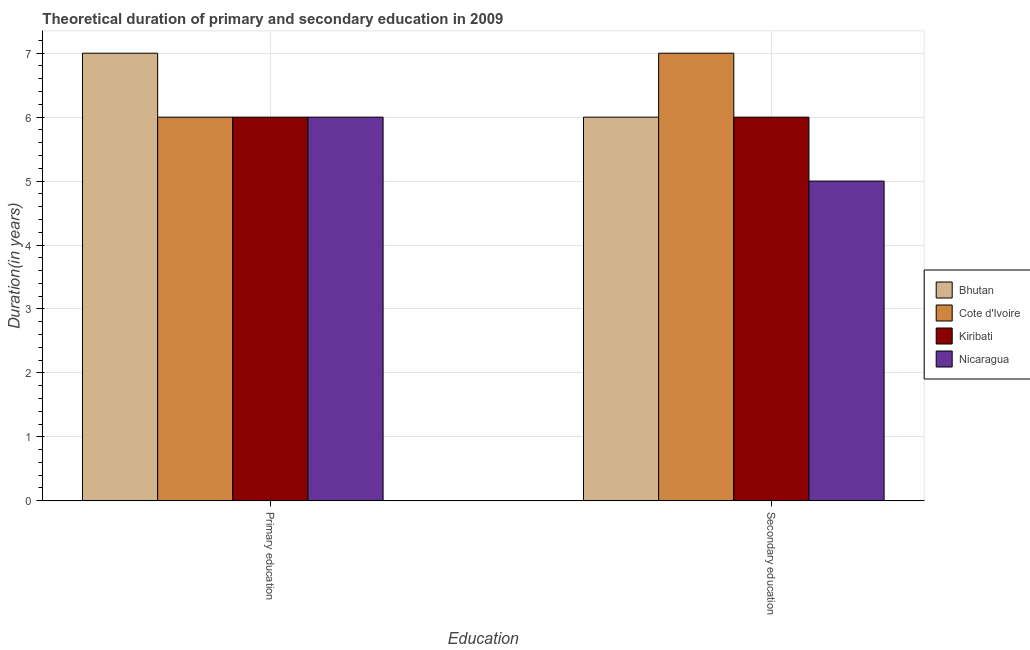How many bars are there on the 2nd tick from the right?
Keep it short and to the point. 4. What is the label of the 1st group of bars from the left?
Offer a terse response. Primary education. What is the duration of primary education in Cote d'Ivoire?
Make the answer very short. 6. Across all countries, what is the maximum duration of primary education?
Offer a very short reply. 7. In which country was the duration of secondary education maximum?
Your response must be concise. Cote d'Ivoire. In which country was the duration of secondary education minimum?
Offer a very short reply. Nicaragua. What is the total duration of primary education in the graph?
Your answer should be very brief. 25. What is the difference between the duration of secondary education in Nicaragua and that in Kiribati?
Keep it short and to the point. -1. What is the difference between the duration of secondary education in Cote d'Ivoire and the duration of primary education in Kiribati?
Offer a very short reply. 1. What is the average duration of primary education per country?
Your response must be concise. 6.25. What is the difference between the duration of secondary education and duration of primary education in Kiribati?
Your response must be concise. 0. In how many countries, is the duration of primary education greater than 5.6 years?
Your answer should be very brief. 4. Is the duration of primary education in Kiribati less than that in Cote d'Ivoire?
Keep it short and to the point. No. What does the 4th bar from the left in Secondary education represents?
Provide a succinct answer. Nicaragua. What does the 3rd bar from the right in Primary education represents?
Your response must be concise. Cote d'Ivoire. Are all the bars in the graph horizontal?
Make the answer very short. No. How many countries are there in the graph?
Your answer should be compact. 4. What is the difference between two consecutive major ticks on the Y-axis?
Make the answer very short. 1. Are the values on the major ticks of Y-axis written in scientific E-notation?
Your response must be concise. No. How many legend labels are there?
Give a very brief answer. 4. What is the title of the graph?
Keep it short and to the point. Theoretical duration of primary and secondary education in 2009. Does "Cameroon" appear as one of the legend labels in the graph?
Make the answer very short. No. What is the label or title of the X-axis?
Your answer should be very brief. Education. What is the label or title of the Y-axis?
Your answer should be very brief. Duration(in years). What is the Duration(in years) of Bhutan in Primary education?
Your answer should be very brief. 7. What is the Duration(in years) in Cote d'Ivoire in Primary education?
Give a very brief answer. 6. What is the Duration(in years) in Cote d'Ivoire in Secondary education?
Make the answer very short. 7. What is the Duration(in years) of Nicaragua in Secondary education?
Provide a short and direct response. 5. Across all Education, what is the maximum Duration(in years) in Nicaragua?
Your response must be concise. 6. Across all Education, what is the minimum Duration(in years) of Bhutan?
Keep it short and to the point. 6. Across all Education, what is the minimum Duration(in years) of Kiribati?
Keep it short and to the point. 6. What is the total Duration(in years) in Bhutan in the graph?
Provide a succinct answer. 13. What is the total Duration(in years) of Cote d'Ivoire in the graph?
Offer a very short reply. 13. What is the total Duration(in years) of Kiribati in the graph?
Make the answer very short. 12. What is the difference between the Duration(in years) of Bhutan in Primary education and that in Secondary education?
Provide a succinct answer. 1. What is the difference between the Duration(in years) in Kiribati in Primary education and that in Secondary education?
Give a very brief answer. 0. What is the average Duration(in years) of Cote d'Ivoire per Education?
Keep it short and to the point. 6.5. What is the difference between the Duration(in years) of Bhutan and Duration(in years) of Nicaragua in Primary education?
Give a very brief answer. 1. What is the difference between the Duration(in years) in Cote d'Ivoire and Duration(in years) in Kiribati in Primary education?
Your answer should be very brief. 0. What is the difference between the Duration(in years) of Kiribati and Duration(in years) of Nicaragua in Primary education?
Provide a short and direct response. 0. What is the difference between the Duration(in years) in Bhutan and Duration(in years) in Cote d'Ivoire in Secondary education?
Provide a succinct answer. -1. What is the difference between the Duration(in years) in Bhutan and Duration(in years) in Kiribati in Secondary education?
Make the answer very short. 0. What is the difference between the Duration(in years) of Cote d'Ivoire and Duration(in years) of Kiribati in Secondary education?
Your answer should be compact. 1. What is the difference between the Duration(in years) of Kiribati and Duration(in years) of Nicaragua in Secondary education?
Keep it short and to the point. 1. What is the ratio of the Duration(in years) of Bhutan in Primary education to that in Secondary education?
Your answer should be very brief. 1.17. What is the ratio of the Duration(in years) of Kiribati in Primary education to that in Secondary education?
Provide a succinct answer. 1. What is the ratio of the Duration(in years) of Nicaragua in Primary education to that in Secondary education?
Provide a succinct answer. 1.2. What is the difference between the highest and the second highest Duration(in years) in Bhutan?
Offer a very short reply. 1. What is the difference between the highest and the second highest Duration(in years) of Cote d'Ivoire?
Ensure brevity in your answer.  1. What is the difference between the highest and the second highest Duration(in years) of Kiribati?
Offer a very short reply. 0. What is the difference between the highest and the lowest Duration(in years) in Bhutan?
Provide a short and direct response. 1. What is the difference between the highest and the lowest Duration(in years) of Cote d'Ivoire?
Provide a succinct answer. 1. What is the difference between the highest and the lowest Duration(in years) in Kiribati?
Offer a terse response. 0. What is the difference between the highest and the lowest Duration(in years) in Nicaragua?
Ensure brevity in your answer.  1. 